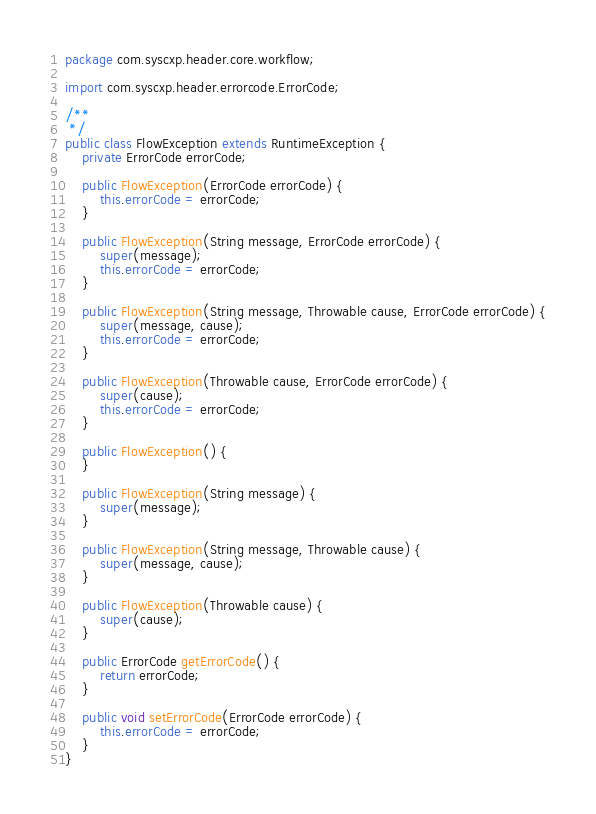Convert code to text. <code><loc_0><loc_0><loc_500><loc_500><_Java_>package com.syscxp.header.core.workflow;

import com.syscxp.header.errorcode.ErrorCode;

/**
 */
public class FlowException extends RuntimeException {
    private ErrorCode errorCode;

    public FlowException(ErrorCode errorCode) {
        this.errorCode = errorCode;
    }

    public FlowException(String message, ErrorCode errorCode) {
        super(message);
        this.errorCode = errorCode;
    }

    public FlowException(String message, Throwable cause, ErrorCode errorCode) {
        super(message, cause);
        this.errorCode = errorCode;
    }

    public FlowException(Throwable cause, ErrorCode errorCode) {
        super(cause);
        this.errorCode = errorCode;
    }

    public FlowException() {
    }

    public FlowException(String message) {
        super(message);
    }

    public FlowException(String message, Throwable cause) {
        super(message, cause);
    }

    public FlowException(Throwable cause) {
        super(cause);
    }

    public ErrorCode getErrorCode() {
        return errorCode;
    }

    public void setErrorCode(ErrorCode errorCode) {
        this.errorCode = errorCode;
    }
}
</code> 